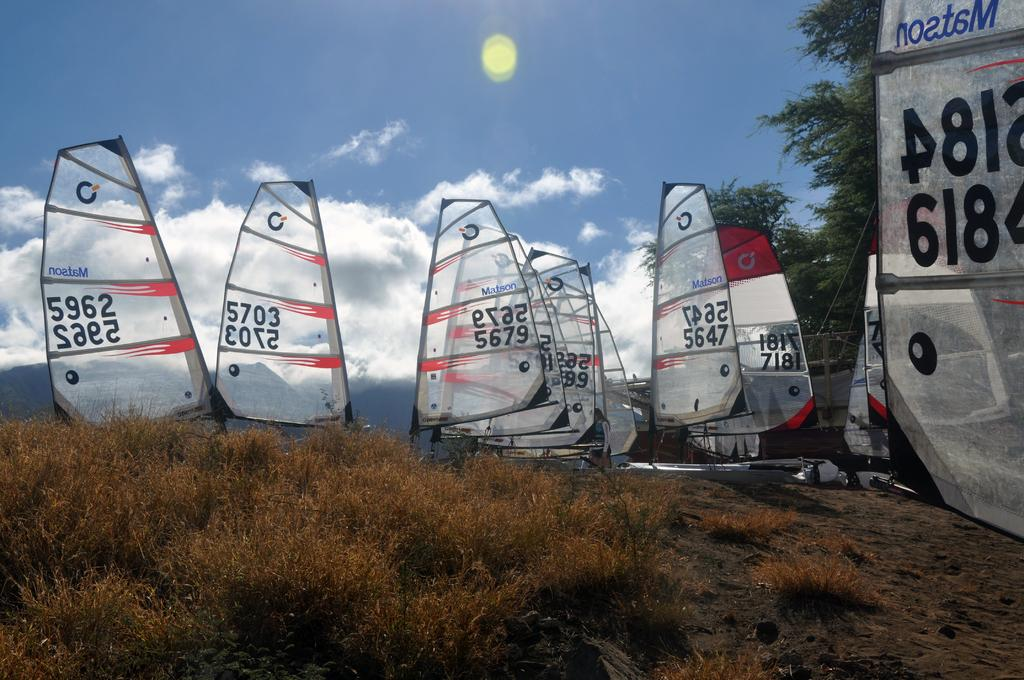What type of vehicles can be seen in the image? There are sailing boats in the image. What type of vegetation is visible in the image? Grass and trees are present in the image. What can be seen in the sky in the image? Clouds and the sky are visible in the image. Are there any words or letters in the image? Yes, there is writing in multiple places in the image. Can you tell me how many beggars are present in the image? There are no beggars present in the image. What type of tool is being used by the person in the image? There is no person or tool visible in the image. 